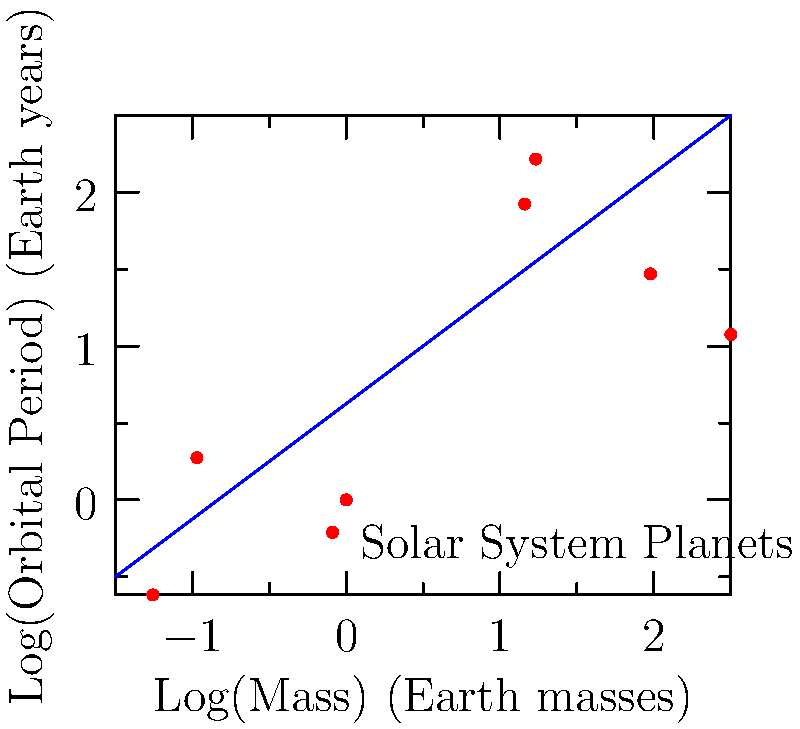Given the logarithmic plot of mass vs. orbital period for the planets in our solar system, what is the approximate slope of the best-fit line? How does this relate to Kepler's Third Law of Planetary Motion? To answer this question, we need to follow these steps:

1. Observe the logarithmic plot: The x-axis represents log(Mass) in Earth masses, and the y-axis represents log(Orbital Period) in Earth years.

2. Estimate the slope: The slope of the best-fit line can be approximated by looking at the overall trend of the data points. In this case, the slope appears to be close to 1/3.

3. Recall Kepler's Third Law: Kepler's Third Law states that the square of the orbital period of a planet is directly proportional to the cube of the semi-major axis of its orbit. Mathematically, this can be expressed as:

   $$T^2 \propto a^3$$

   Where $T$ is the orbital period and $a$ is the semi-major axis.

4. Relate mass to semi-major axis: For a circular orbit (a good approximation for most planets), we can use the relation:

   $$a^3 \propto M$$

   Where $M$ is the mass of the central body (in this case, the Sun).

5. Combine the relationships: Substituting the mass-semi-major axis relation into Kepler's Third Law:

   $$T^2 \propto M$$

6. Take the logarithm of both sides:

   $$\log(T^2) \propto \log(M)$$
   $$2\log(T) \propto \log(M)$$
   $$\log(T) \propto \frac{1}{2}\log(M)$$

7. Interpret the result: This logarithmic relationship shows that on a log-log plot, we expect a slope of 1/2 between orbital period and the mass of the central body. However, our plot shows the relationship between a planet's mass and its orbital period, which is the inverse of this relationship. Therefore, we expect a slope of 1/3.

The observed slope of approximately 1/3 in the plot aligns with this theoretical prediction, confirming the relationship derived from Kepler's Third Law.
Answer: Slope ≈ 1/3, confirming Kepler's Third Law 